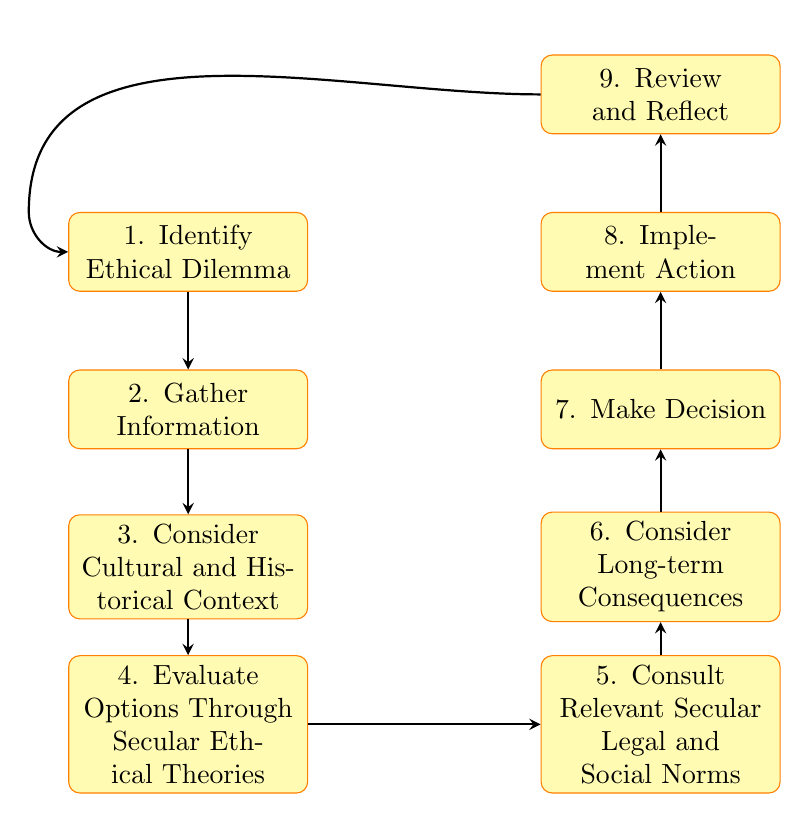What is the first step in the decision-making process? The first step is "Identify Ethical Dilemma," which is the starting point of the flowchart.
Answer: Identify Ethical Dilemma How many steps are there in total within the diagram? The diagram includes nine steps that guide the decision-making process, numbered from 1 to 9.
Answer: Nine What is the node directly below "Gather Information"? Directly below "Gather Information" is "Consider Cultural and Historical Context," which follows the collection of relevant facts.
Answer: Consider Cultural and Historical Context Which step comes after "Make Decision"? "Implement Action" follows "Make Decision," indicating the action taken based on the decision made.
Answer: Implement Action What is considered in step 3? Step 3 includes "Consider Cultural and Historical Context," which involves reflecting on cultural and historical factors relevant to the ethical dilemma.
Answer: Consider Cultural and Historical Context Which two steps come before "Evaluate Options Through Secular Ethical Theories"? "Gather Information" and "Consider Cultural and Historical Context" are the two steps that come before "Evaluate Options Through Secular Ethical Theories" in the process.
Answer: Gather Information, Consider Cultural and Historical Context What is the final step in the flowchart? The last step of the flowchart is "Review and Reflect," which assesses the outcome and process of the decision made.
Answer: Review and Reflect What is the relationship between "Consult Relevant Secular Legal and Social Norms" and "Consider Long-term Consequences"? "Consult Relevant Secular Legal and Social Norms" occurs to the right of "Evaluate Options Through Secular Ethical Theories," while "Consider Long-term Consequences" is above it, suggesting they are parallel considerations.
Answer: Parallel considerations 